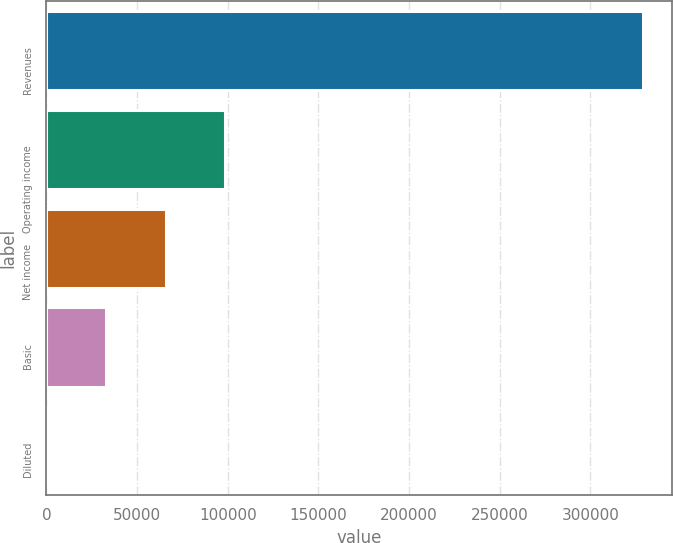Convert chart. <chart><loc_0><loc_0><loc_500><loc_500><bar_chart><fcel>Revenues<fcel>Operating income<fcel>Net income<fcel>Basic<fcel>Diluted<nl><fcel>328827<fcel>98648.3<fcel>65765.6<fcel>32882.9<fcel>0.26<nl></chart> 